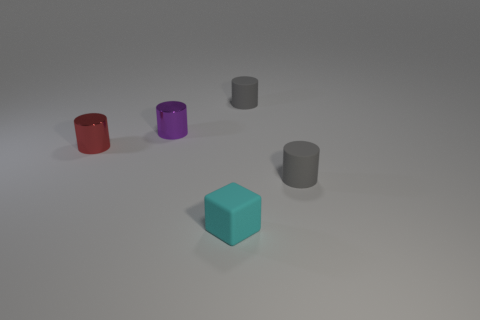Add 1 gray things. How many objects exist? 6 Subtract all purple cylinders. How many cylinders are left? 3 Subtract all cylinders. How many objects are left? 1 Subtract 1 cylinders. How many cylinders are left? 3 Subtract all purple cylinders. Subtract all yellow blocks. How many cylinders are left? 3 Subtract all cyan spheres. How many purple cylinders are left? 1 Subtract all small rubber things. Subtract all small red cylinders. How many objects are left? 1 Add 2 small cyan things. How many small cyan things are left? 3 Add 4 small rubber blocks. How many small rubber blocks exist? 5 Subtract 1 cyan cubes. How many objects are left? 4 